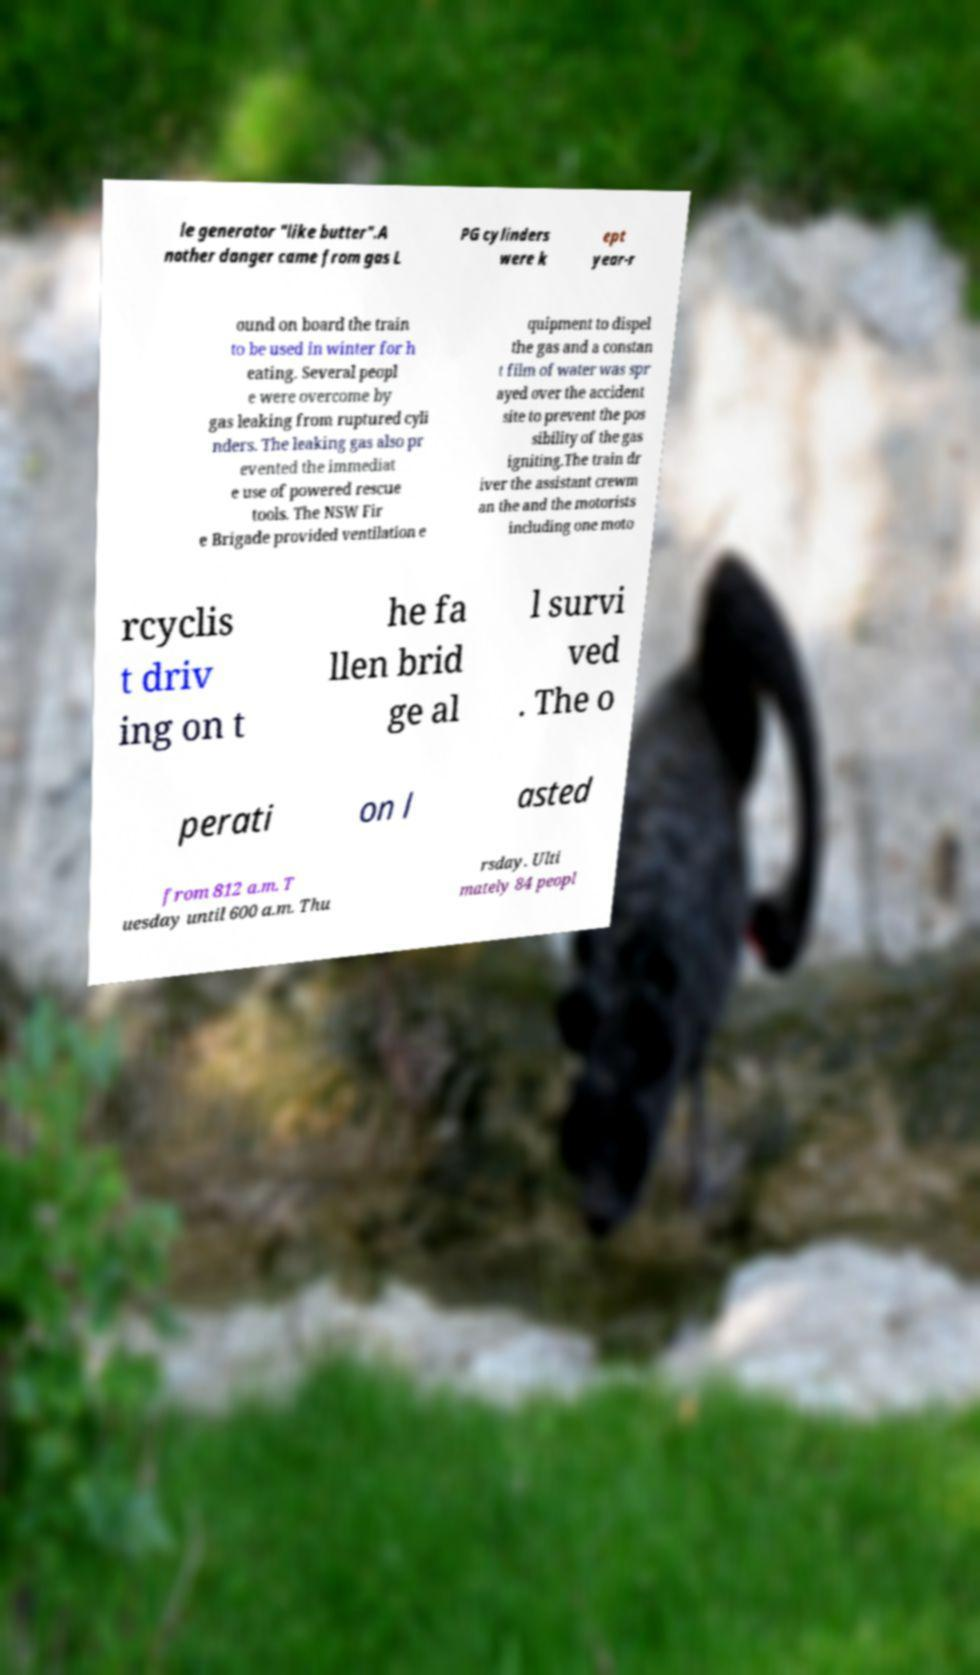I need the written content from this picture converted into text. Can you do that? le generator "like butter".A nother danger came from gas L PG cylinders were k ept year-r ound on board the train to be used in winter for h eating. Several peopl e were overcome by gas leaking from ruptured cyli nders. The leaking gas also pr evented the immediat e use of powered rescue tools. The NSW Fir e Brigade provided ventilation e quipment to dispel the gas and a constan t film of water was spr ayed over the accident site to prevent the pos sibility of the gas igniting.The train dr iver the assistant crewm an the and the motorists including one moto rcyclis t driv ing on t he fa llen brid ge al l survi ved . The o perati on l asted from 812 a.m. T uesday until 600 a.m. Thu rsday. Ulti mately 84 peopl 